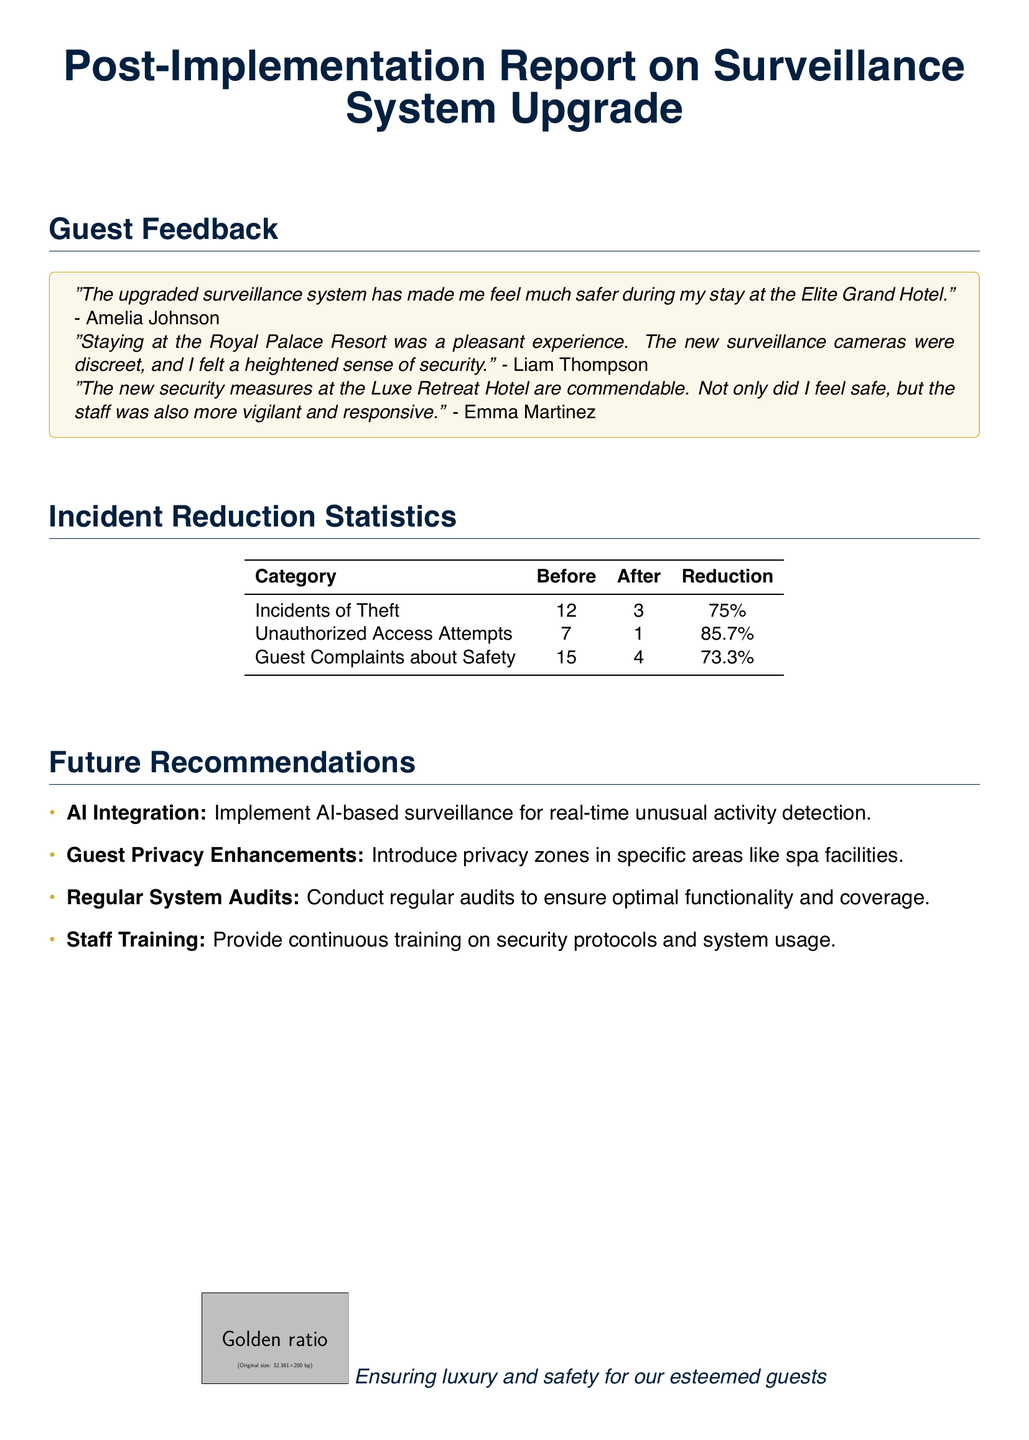What was the percentage reduction in incidents of theft? The document states that the incidents of theft reduced from 12 to 3, which is a reduction of 75%.
Answer: 75% Who expressed feeling safer during their stay? The document includes a quote from Amelia Johnson stating that the upgraded surveillance system made her feel safer.
Answer: Amelia Johnson What was the reduction in guest complaints about safety? According to the document, guest complaints about safety reduced from 15 to 4, which is a reduction of 73.3%.
Answer: 73.3% What is one of the future recommendations regarding privacy? The document mentions "Guest Privacy Enhancements" as a recommendation, specifically introducing privacy zones in specific areas.
Answer: Guest Privacy Enhancements How many unauthorized access attempts were recorded after the upgrade? The document shows that unauthorized access attempts dropped from 7 to 1 after the upgrade.
Answer: 1 